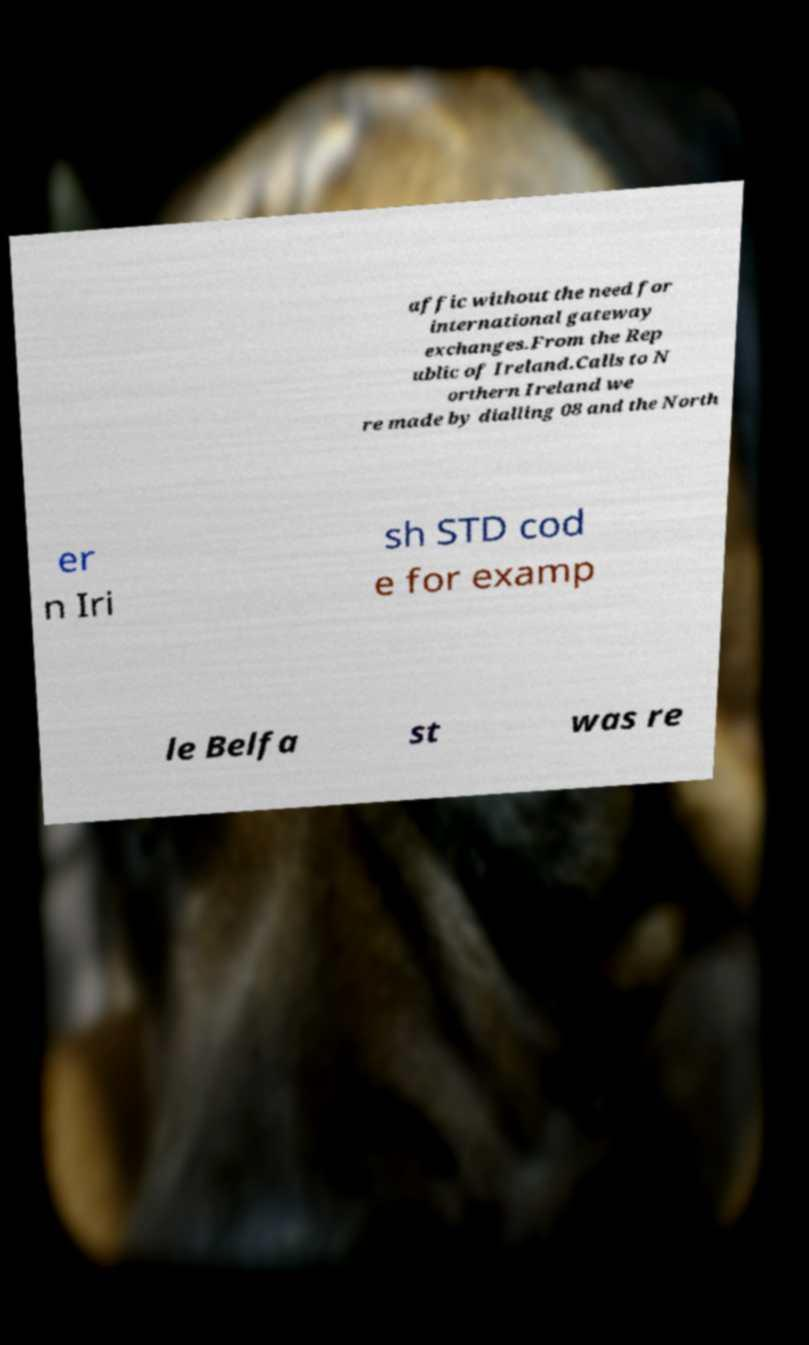Please identify and transcribe the text found in this image. affic without the need for international gateway exchanges.From the Rep ublic of Ireland.Calls to N orthern Ireland we re made by dialling 08 and the North er n Iri sh STD cod e for examp le Belfa st was re 